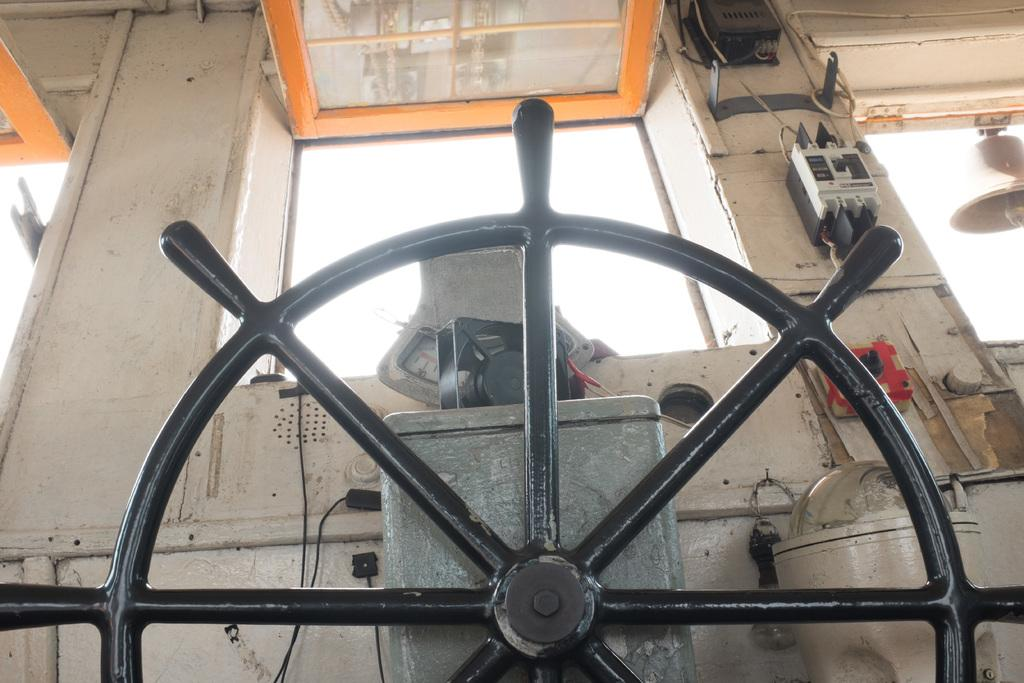What is the main object in the center of the image? There is a steering wheel in the center of the image. What can be seen in the background of the image? There is a fuse, a window, the sky, and a bell in the background of the image. How many passengers are visible in the image? There are no passengers visible in the image; it only features a steering wheel and objects in the background. 